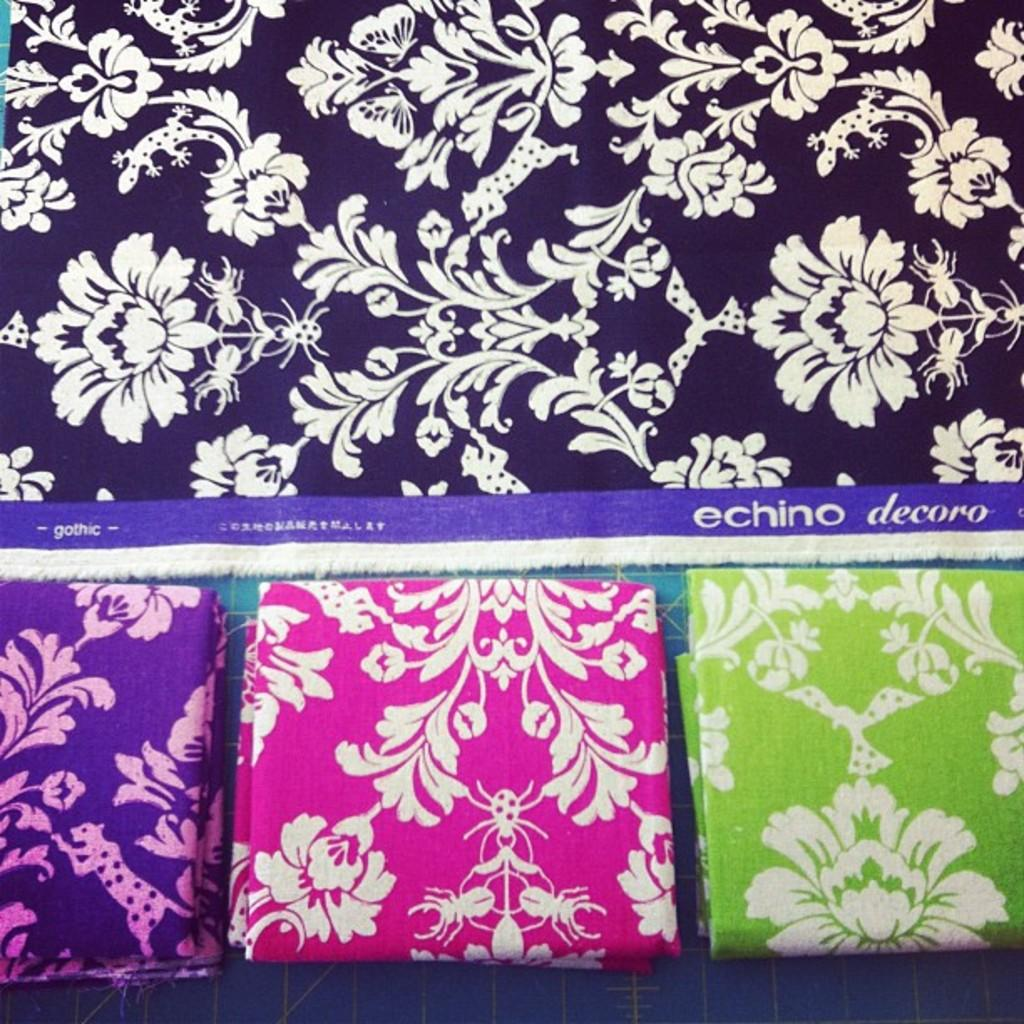What is present in the image? There are clothes in the image. Where are the clothes located? The clothes are on a platform. What type of worm can be seen crawling on the clothes in the image? There is no worm present in the image; it only features clothes on a platform. 